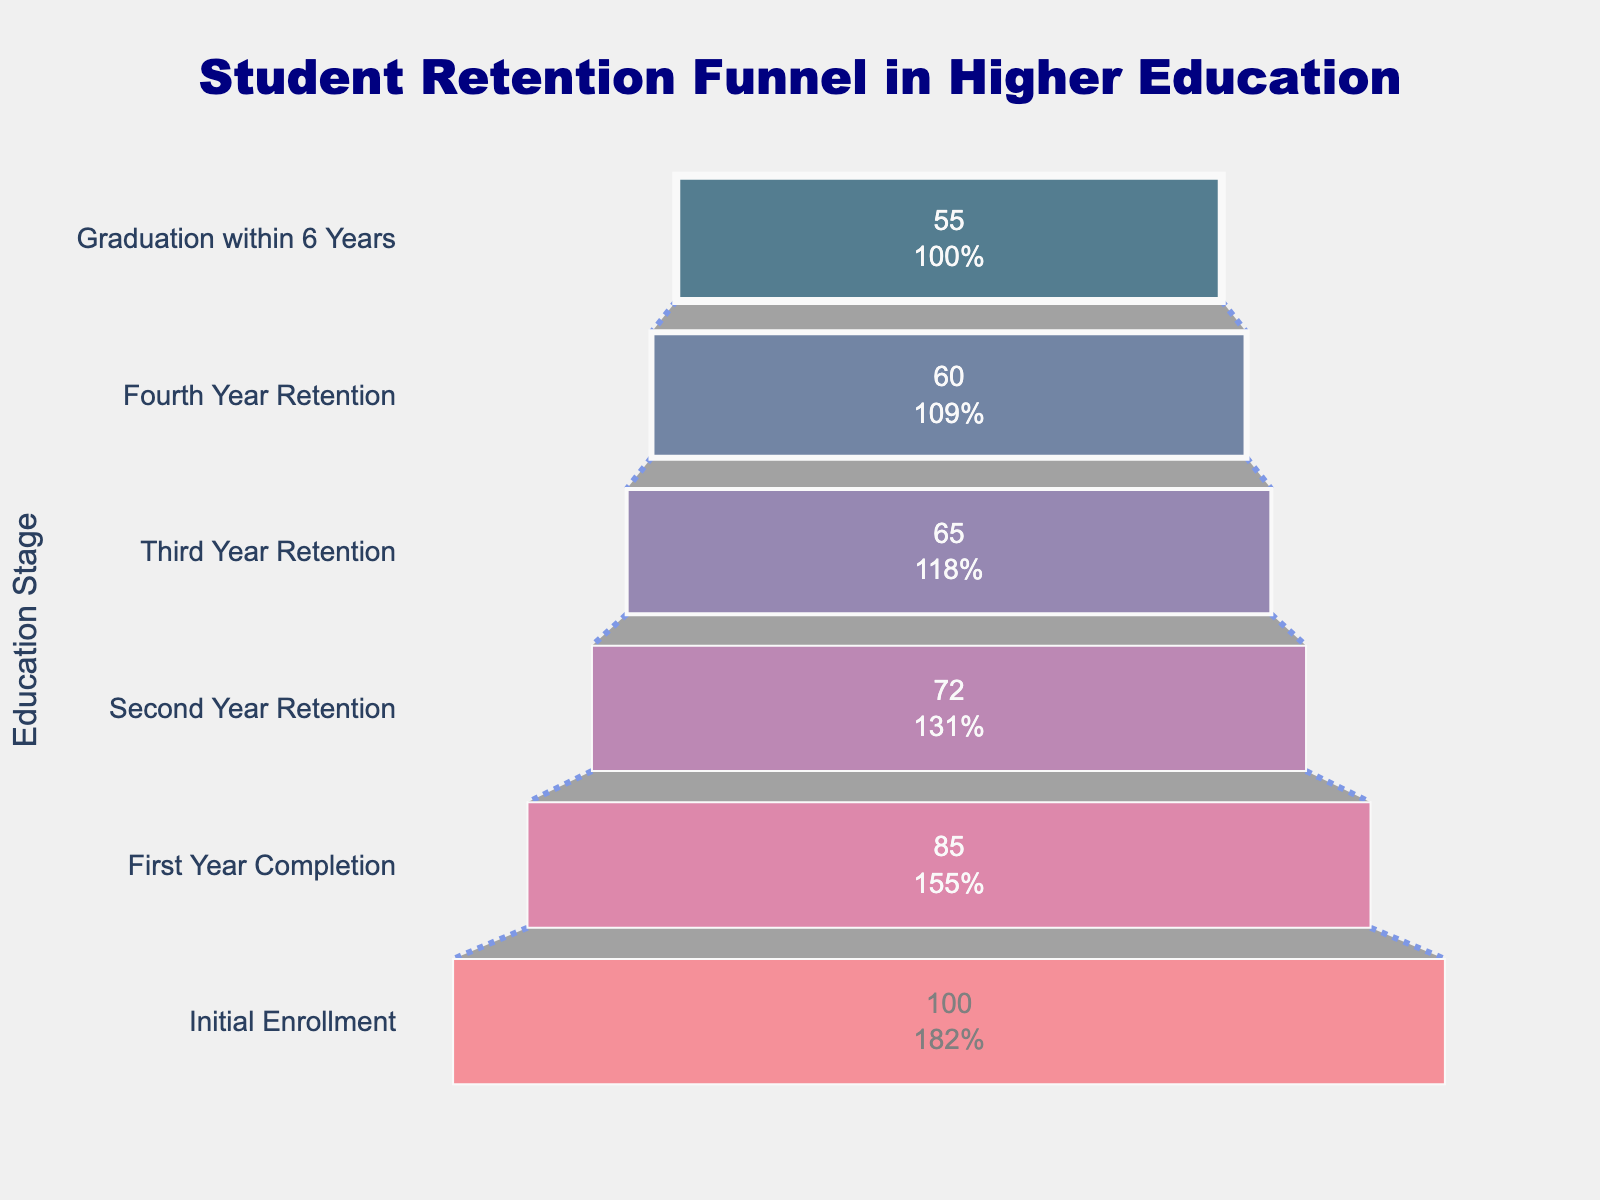what is the title of the figure? The title is located at the top center of the figure and it reads "Student Retention Funnel in Higher Education".
Answer: Student Retention Funnel in Higher Education What is the percentage of students who completed the first year? The retention rate at the stage labeled "First Year Completion" is shown as a percentage value of 85%.
Answer: 85% How many stages are there in the funnel chart? Counting the number of unique stages listed on the y-axis, there are six stages in total.
Answer: Six What stage has the lowest retention percentage? The stage with the lowest percentage, as shown on the funnel chart, is "Graduation within 6 Years" which has a 55% retention rate.
Answer: Graduation within 6 Years What is the percentage difference between the "Second Year Retention" and "Graduation within 6 Years"? Subtract the retention percentage of "Graduation within 6 Years" from that of "Second Year Retention": 72% - 55% = 17%.
Answer: 17% Compare the percentages of "Third Year Retention" and "Fourth Year Retention". Which has a higher retention rate? By comparing the figures on the funnel chart, "Third Year Retention" has a 65% retention rate, which is higher than the 60% retention rate of "Fourth Year Retention".
Answer: Third Year Retention What percentage of students who initially enrolled drop out after the first year? To find the dropout rate, subtract the "First Year Completion" rate from 100%: 100% - 85% = 15%.
Answer: 15% What is the average retention rate from "Initial Enrollment" to "Graduation within 6 Years"? Average is calculated by summing all percentages and dividing by the number of stages: (100 + 85 + 72 + 65 + 60 + 55) / 6 ≈ 72.83%.
Answer: Approximately 72.83% In which stage is the greatest drop in retention observed? The greatest drop can be observed by finding the largest difference between successive stages. The largest drop is between "First Year Completion" (85%) and "Second Year Retention" (72%): 85% - 72% = 13%.
Answer: Between First Year Completion and Second Year Retention Is the trend in the student retention rate increasing, decreasing, or constant? Observing the funnel chart, the retention percentages decrease at each subsequent stage from "Initial Enrollment" to "Graduation within 6 Years", indicating a decreasing trend.
Answer: Decreasing 